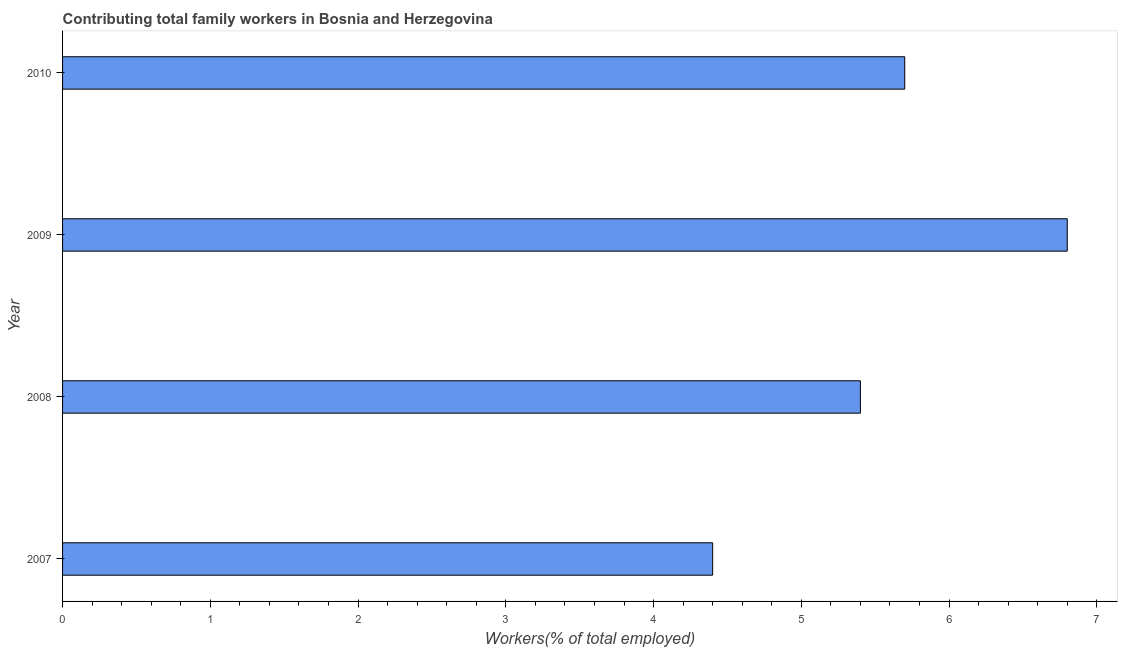Does the graph contain any zero values?
Offer a very short reply. No. What is the title of the graph?
Your answer should be compact. Contributing total family workers in Bosnia and Herzegovina. What is the label or title of the X-axis?
Offer a very short reply. Workers(% of total employed). What is the contributing family workers in 2009?
Ensure brevity in your answer.  6.8. Across all years, what is the maximum contributing family workers?
Make the answer very short. 6.8. Across all years, what is the minimum contributing family workers?
Your answer should be very brief. 4.4. What is the sum of the contributing family workers?
Make the answer very short. 22.3. What is the difference between the contributing family workers in 2008 and 2010?
Make the answer very short. -0.3. What is the average contributing family workers per year?
Make the answer very short. 5.58. What is the median contributing family workers?
Make the answer very short. 5.55. In how many years, is the contributing family workers greater than 2.8 %?
Offer a very short reply. 4. What is the ratio of the contributing family workers in 2007 to that in 2010?
Give a very brief answer. 0.77. In how many years, is the contributing family workers greater than the average contributing family workers taken over all years?
Offer a terse response. 2. How many bars are there?
Offer a terse response. 4. What is the difference between two consecutive major ticks on the X-axis?
Provide a succinct answer. 1. What is the Workers(% of total employed) of 2007?
Your answer should be compact. 4.4. What is the Workers(% of total employed) of 2008?
Offer a terse response. 5.4. What is the Workers(% of total employed) of 2009?
Your answer should be very brief. 6.8. What is the Workers(% of total employed) of 2010?
Provide a succinct answer. 5.7. What is the difference between the Workers(% of total employed) in 2007 and 2008?
Your response must be concise. -1. What is the difference between the Workers(% of total employed) in 2007 and 2009?
Your response must be concise. -2.4. What is the difference between the Workers(% of total employed) in 2007 and 2010?
Make the answer very short. -1.3. What is the difference between the Workers(% of total employed) in 2008 and 2009?
Make the answer very short. -1.4. What is the difference between the Workers(% of total employed) in 2009 and 2010?
Keep it short and to the point. 1.1. What is the ratio of the Workers(% of total employed) in 2007 to that in 2008?
Offer a terse response. 0.81. What is the ratio of the Workers(% of total employed) in 2007 to that in 2009?
Make the answer very short. 0.65. What is the ratio of the Workers(% of total employed) in 2007 to that in 2010?
Give a very brief answer. 0.77. What is the ratio of the Workers(% of total employed) in 2008 to that in 2009?
Your answer should be very brief. 0.79. What is the ratio of the Workers(% of total employed) in 2008 to that in 2010?
Provide a succinct answer. 0.95. What is the ratio of the Workers(% of total employed) in 2009 to that in 2010?
Your answer should be compact. 1.19. 